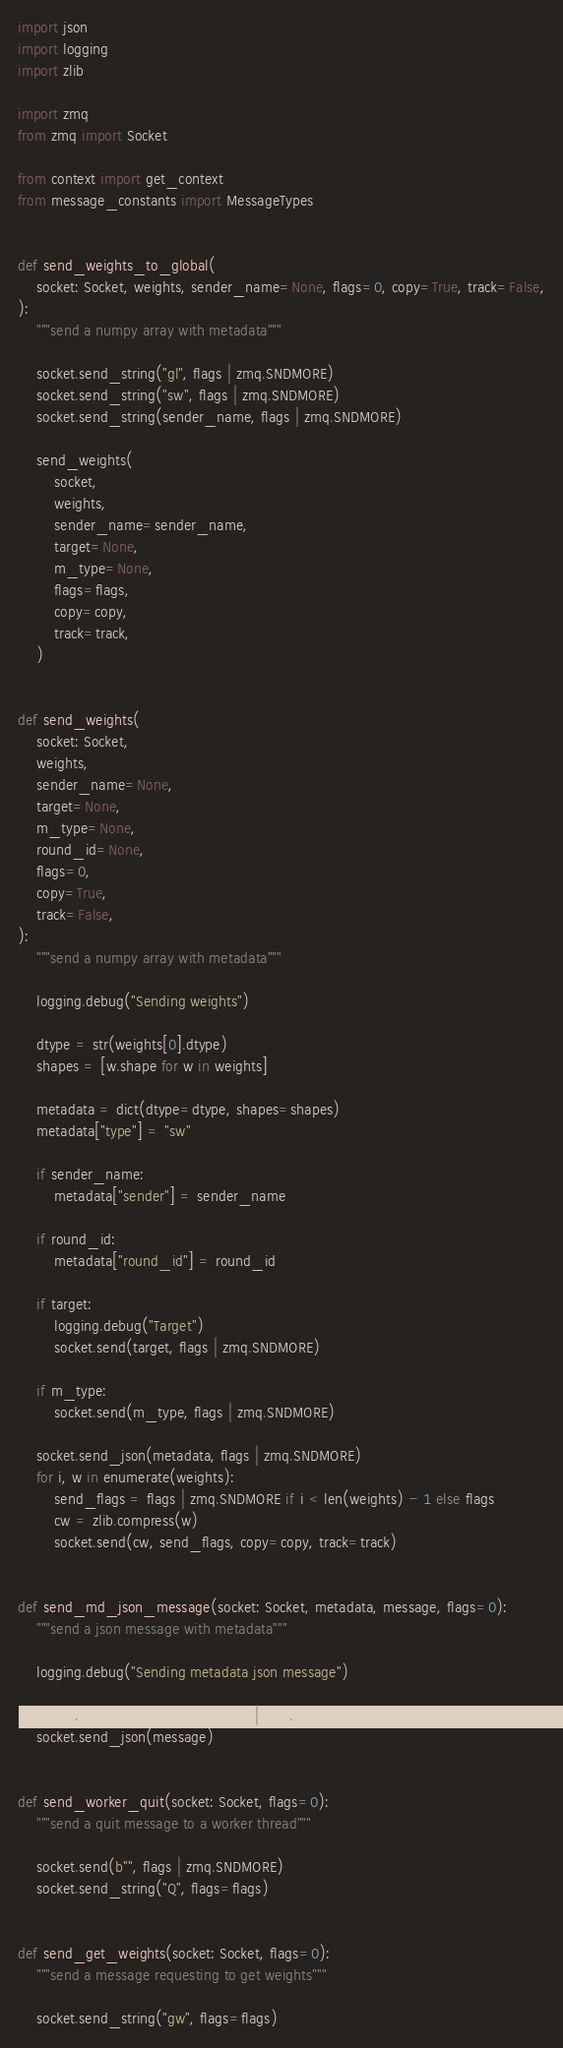<code> <loc_0><loc_0><loc_500><loc_500><_Python_>import json
import logging
import zlib

import zmq
from zmq import Socket

from context import get_context
from message_constants import MessageTypes


def send_weights_to_global(
    socket: Socket, weights, sender_name=None, flags=0, copy=True, track=False,
):
    """send a numpy array with metadata"""

    socket.send_string("gl", flags | zmq.SNDMORE)
    socket.send_string("sw", flags | zmq.SNDMORE)
    socket.send_string(sender_name, flags | zmq.SNDMORE)

    send_weights(
        socket,
        weights,
        sender_name=sender_name,
        target=None,
        m_type=None,
        flags=flags,
        copy=copy,
        track=track,
    )


def send_weights(
    socket: Socket,
    weights,
    sender_name=None,
    target=None,
    m_type=None,
    round_id=None,
    flags=0,
    copy=True,
    track=False,
):
    """send a numpy array with metadata"""

    logging.debug("Sending weights")

    dtype = str(weights[0].dtype)
    shapes = [w.shape for w in weights]

    metadata = dict(dtype=dtype, shapes=shapes)
    metadata["type"] = "sw"

    if sender_name:
        metadata["sender"] = sender_name

    if round_id:
        metadata["round_id"] = round_id

    if target:
        logging.debug("Target")
        socket.send(target, flags | zmq.SNDMORE)

    if m_type:
        socket.send(m_type, flags | zmq.SNDMORE)

    socket.send_json(metadata, flags | zmq.SNDMORE)
    for i, w in enumerate(weights):
        send_flags = flags | zmq.SNDMORE if i < len(weights) - 1 else flags
        cw = zlib.compress(w)
        socket.send(cw, send_flags, copy=copy, track=track)


def send_md_json_message(socket: Socket, metadata, message, flags=0):
    """send a json message with metadata"""

    logging.debug("Sending metadata json message")

    socket.send_json(metadata, flags | zmq.SNDMORE)
    socket.send_json(message)


def send_worker_quit(socket: Socket, flags=0):
    """send a quit message to a worker thread"""

    socket.send(b"", flags | zmq.SNDMORE)
    socket.send_string("Q", flags=flags)


def send_get_weights(socket: Socket, flags=0):
    """send a message requesting to get weights"""

    socket.send_string("gw", flags=flags)

</code> 